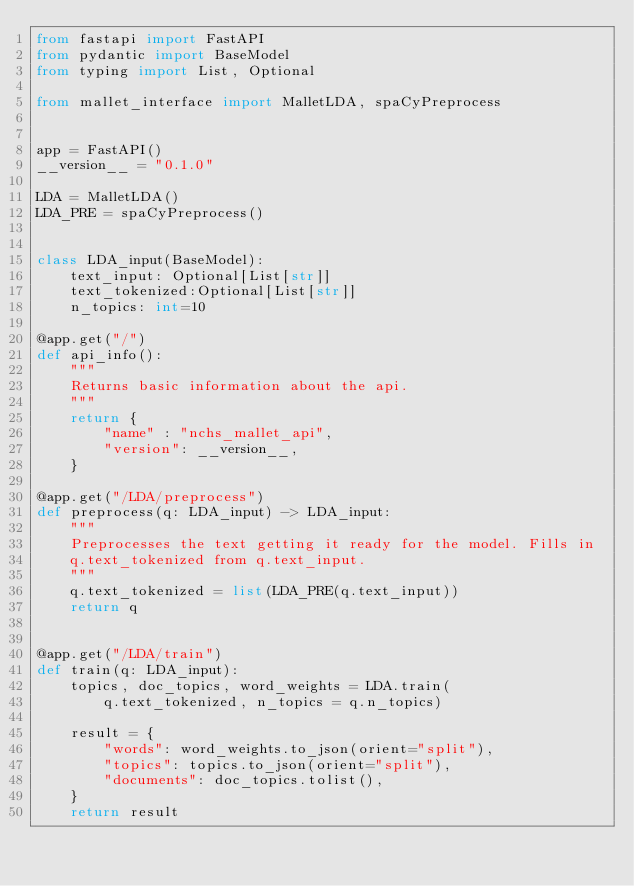Convert code to text. <code><loc_0><loc_0><loc_500><loc_500><_Python_>from fastapi import FastAPI
from pydantic import BaseModel
from typing import List, Optional

from mallet_interface import MalletLDA, spaCyPreprocess


app = FastAPI()
__version__ = "0.1.0"

LDA = MalletLDA()
LDA_PRE = spaCyPreprocess()


class LDA_input(BaseModel):
    text_input: Optional[List[str]]
    text_tokenized:Optional[List[str]]
    n_topics: int=10

@app.get("/")
def api_info():
    """
    Returns basic information about the api.
    """
    return {
        "name" : "nchs_mallet_api",
        "version": __version__,
    }

@app.get("/LDA/preprocess")
def preprocess(q: LDA_input) -> LDA_input:
    """
    Preprocesses the text getting it ready for the model. Fills in
    q.text_tokenized from q.text_input.
    """
    q.text_tokenized = list(LDA_PRE(q.text_input))
    return q


@app.get("/LDA/train")
def train(q: LDA_input):
    topics, doc_topics, word_weights = LDA.train(
        q.text_tokenized, n_topics = q.n_topics)

    result = {
        "words": word_weights.to_json(orient="split"),
        "topics": topics.to_json(orient="split"),
        "documents": doc_topics.tolist(),
    }
    return result
</code> 